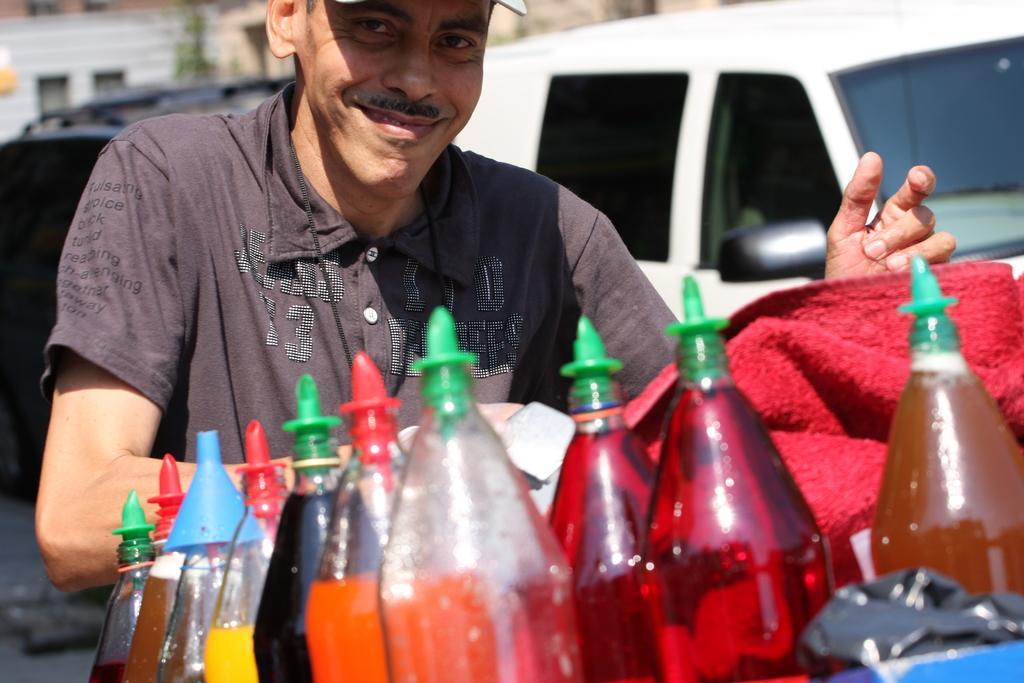In one or two sentences, can you explain what this image depicts? In the image we can see there is a man who is standing and in front there are all juice bottles. 